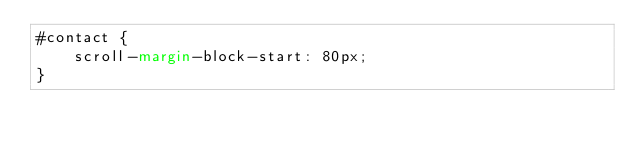Convert code to text. <code><loc_0><loc_0><loc_500><loc_500><_CSS_>#contact {
    scroll-margin-block-start: 80px;
}</code> 